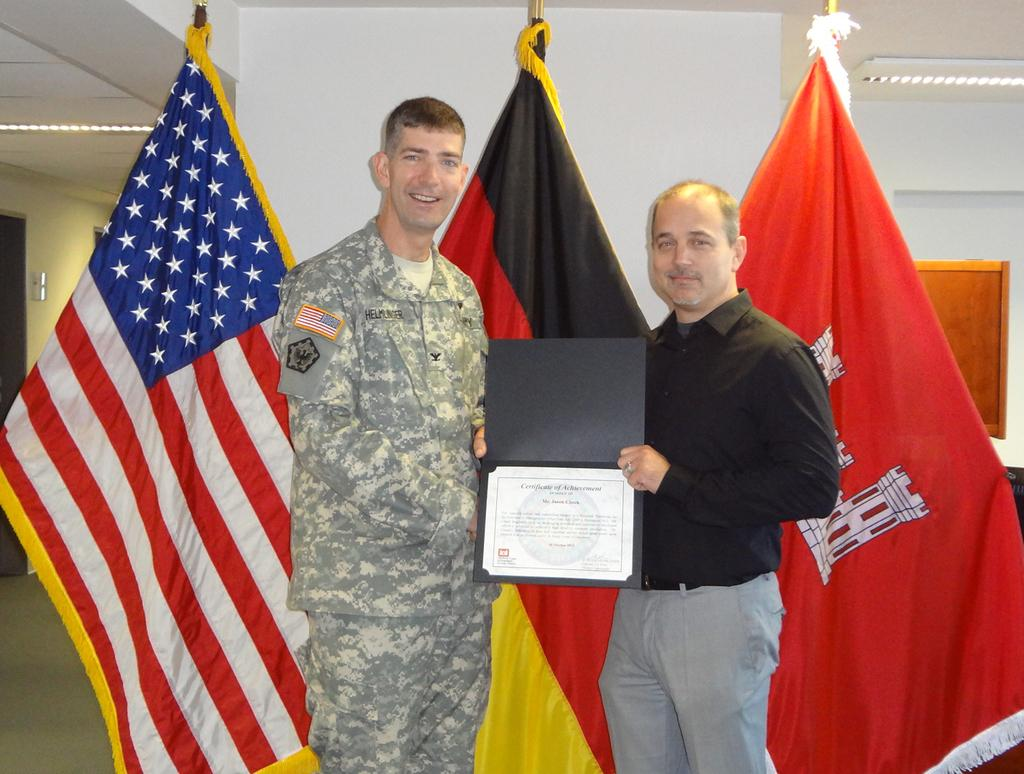<image>
Provide a brief description of the given image. Two men holding a Certificate of Achievement in front of flags. 